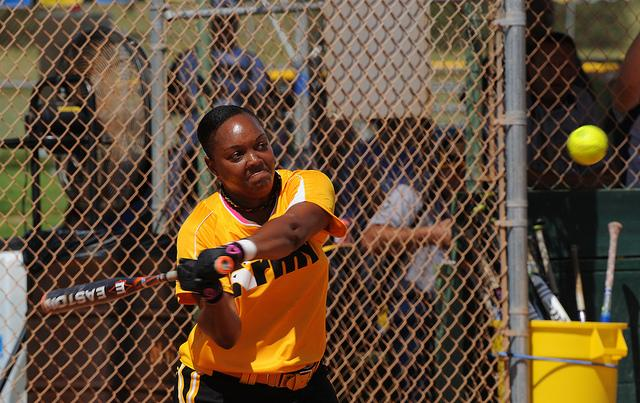Judging by the batters expression how hard is she swinging the bat?

Choices:
A) very soft
B) very hard
C) soft
D) somewhat hard very hard 